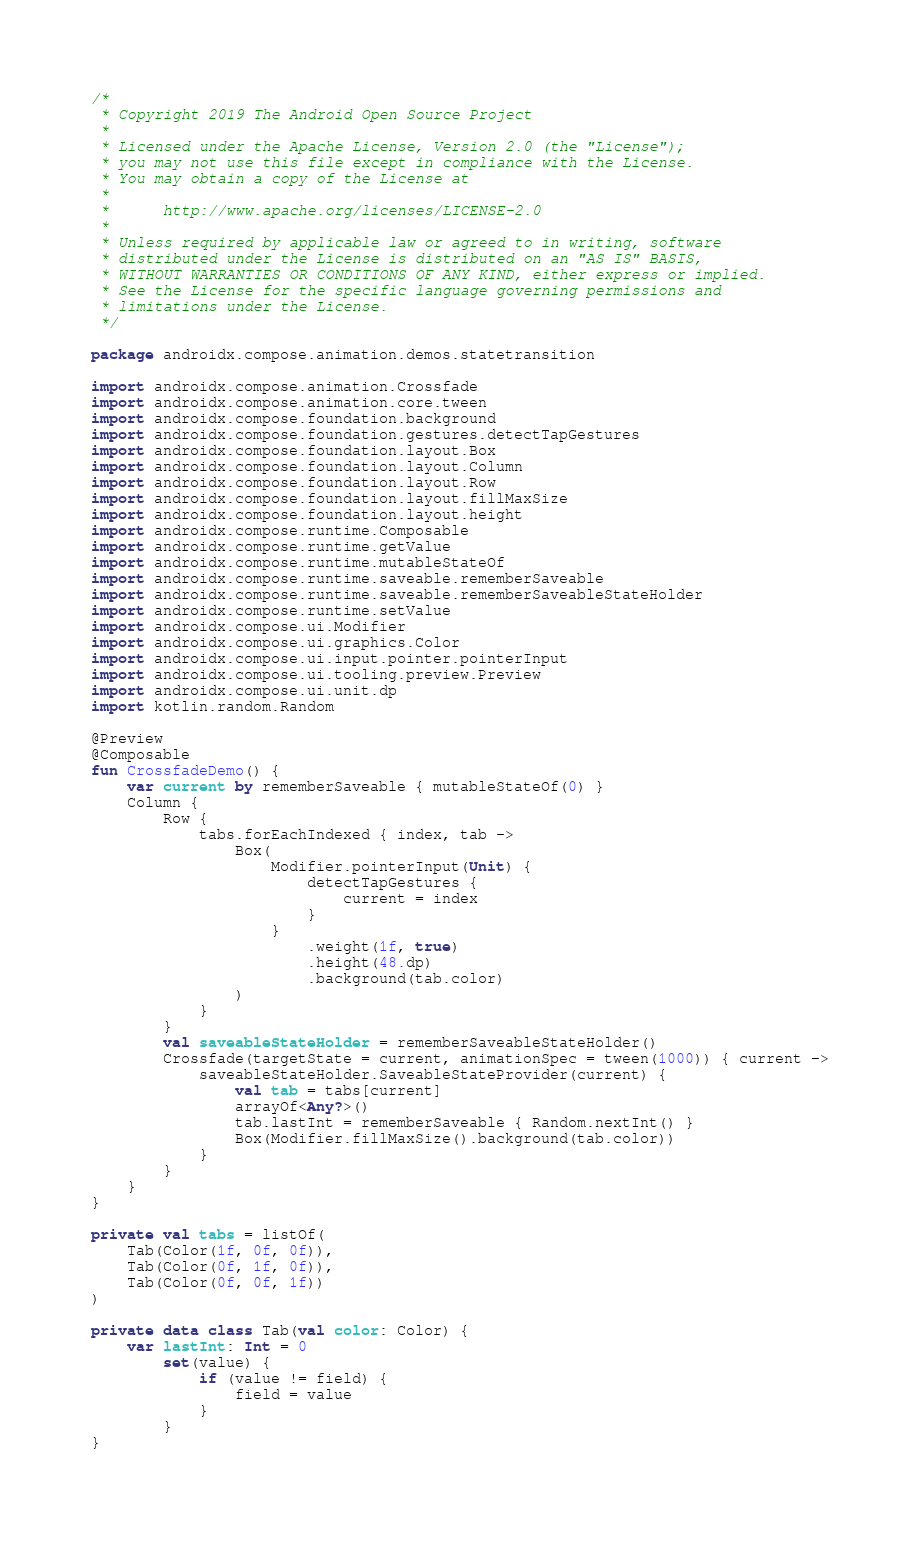Convert code to text. <code><loc_0><loc_0><loc_500><loc_500><_Kotlin_>/*
 * Copyright 2019 The Android Open Source Project
 *
 * Licensed under the Apache License, Version 2.0 (the "License");
 * you may not use this file except in compliance with the License.
 * You may obtain a copy of the License at
 *
 *      http://www.apache.org/licenses/LICENSE-2.0
 *
 * Unless required by applicable law or agreed to in writing, software
 * distributed under the License is distributed on an "AS IS" BASIS,
 * WITHOUT WARRANTIES OR CONDITIONS OF ANY KIND, either express or implied.
 * See the License for the specific language governing permissions and
 * limitations under the License.
 */

package androidx.compose.animation.demos.statetransition

import androidx.compose.animation.Crossfade
import androidx.compose.animation.core.tween
import androidx.compose.foundation.background
import androidx.compose.foundation.gestures.detectTapGestures
import androidx.compose.foundation.layout.Box
import androidx.compose.foundation.layout.Column
import androidx.compose.foundation.layout.Row
import androidx.compose.foundation.layout.fillMaxSize
import androidx.compose.foundation.layout.height
import androidx.compose.runtime.Composable
import androidx.compose.runtime.getValue
import androidx.compose.runtime.mutableStateOf
import androidx.compose.runtime.saveable.rememberSaveable
import androidx.compose.runtime.saveable.rememberSaveableStateHolder
import androidx.compose.runtime.setValue
import androidx.compose.ui.Modifier
import androidx.compose.ui.graphics.Color
import androidx.compose.ui.input.pointer.pointerInput
import androidx.compose.ui.tooling.preview.Preview
import androidx.compose.ui.unit.dp
import kotlin.random.Random

@Preview
@Composable
fun CrossfadeDemo() {
    var current by rememberSaveable { mutableStateOf(0) }
    Column {
        Row {
            tabs.forEachIndexed { index, tab ->
                Box(
                    Modifier.pointerInput(Unit) {
                        detectTapGestures {
                            current = index
                        }
                    }
                        .weight(1f, true)
                        .height(48.dp)
                        .background(tab.color)
                )
            }
        }
        val saveableStateHolder = rememberSaveableStateHolder()
        Crossfade(targetState = current, animationSpec = tween(1000)) { current ->
            saveableStateHolder.SaveableStateProvider(current) {
                val tab = tabs[current]
                arrayOf<Any?>()
                tab.lastInt = rememberSaveable { Random.nextInt() }
                Box(Modifier.fillMaxSize().background(tab.color))
            }
        }
    }
}

private val tabs = listOf(
    Tab(Color(1f, 0f, 0f)),
    Tab(Color(0f, 1f, 0f)),
    Tab(Color(0f, 0f, 1f))
)

private data class Tab(val color: Color) {
    var lastInt: Int = 0
        set(value) {
            if (value != field) {
                field = value
            }
        }
}</code> 